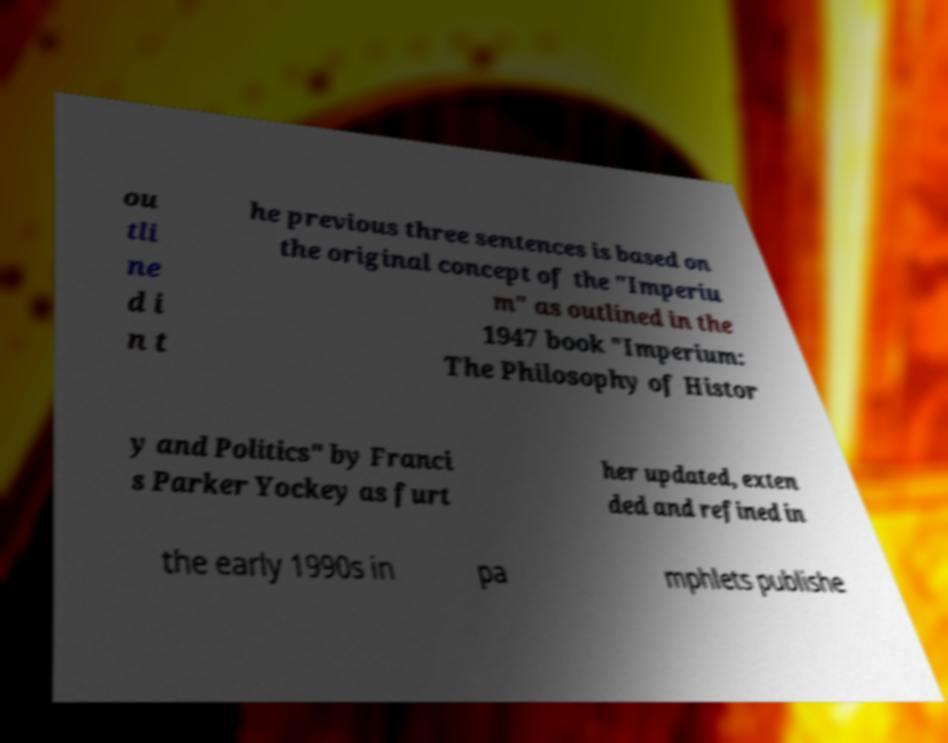There's text embedded in this image that I need extracted. Can you transcribe it verbatim? ou tli ne d i n t he previous three sentences is based on the original concept of the "Imperiu m" as outlined in the 1947 book "Imperium: The Philosophy of Histor y and Politics" by Franci s Parker Yockey as furt her updated, exten ded and refined in the early 1990s in pa mphlets publishe 